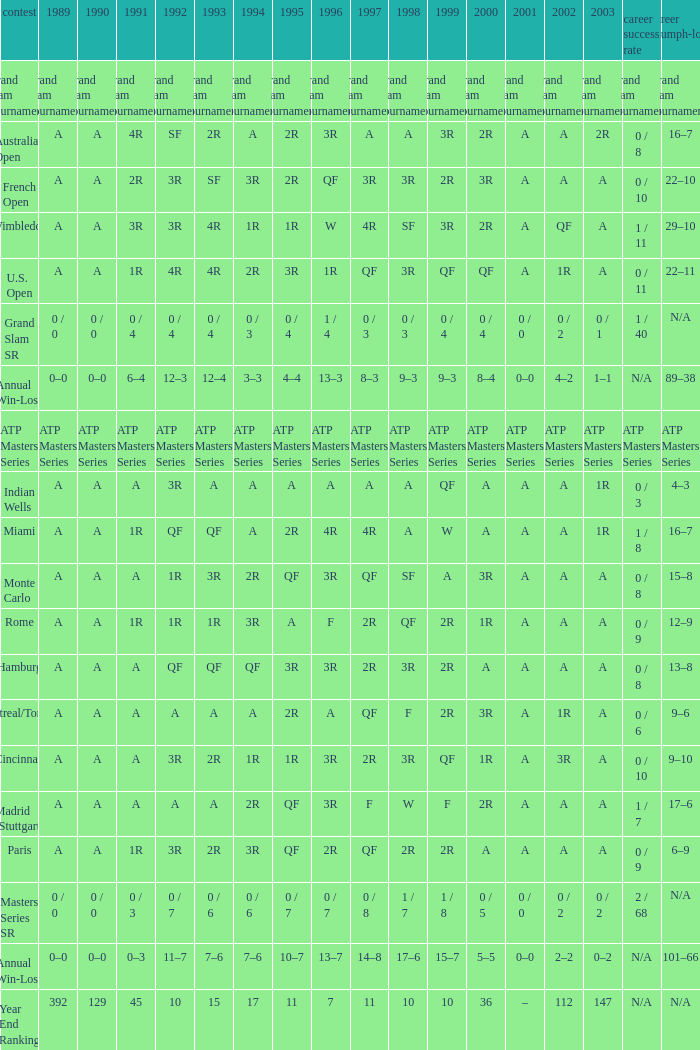What is the value in 1997 when the value in 1989 is A, 1995 is QF, 1996 is 3R and the career SR is 0 / 8? QF. 